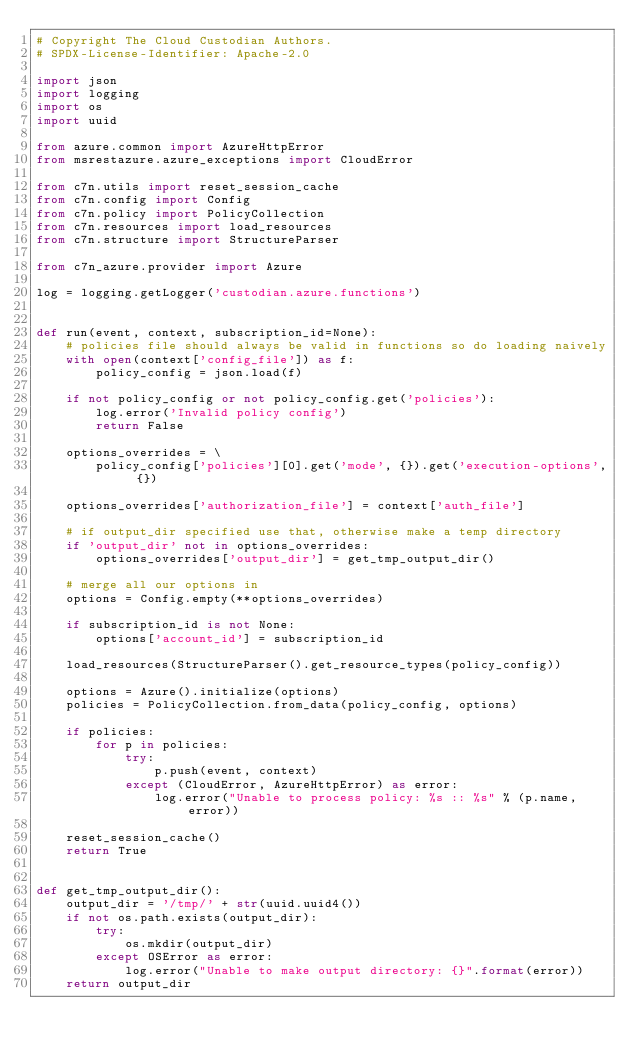Convert code to text. <code><loc_0><loc_0><loc_500><loc_500><_Python_># Copyright The Cloud Custodian Authors.
# SPDX-License-Identifier: Apache-2.0

import json
import logging
import os
import uuid

from azure.common import AzureHttpError
from msrestazure.azure_exceptions import CloudError

from c7n.utils import reset_session_cache
from c7n.config import Config
from c7n.policy import PolicyCollection
from c7n.resources import load_resources
from c7n.structure import StructureParser

from c7n_azure.provider import Azure

log = logging.getLogger('custodian.azure.functions')


def run(event, context, subscription_id=None):
    # policies file should always be valid in functions so do loading naively
    with open(context['config_file']) as f:
        policy_config = json.load(f)

    if not policy_config or not policy_config.get('policies'):
        log.error('Invalid policy config')
        return False

    options_overrides = \
        policy_config['policies'][0].get('mode', {}).get('execution-options', {})

    options_overrides['authorization_file'] = context['auth_file']

    # if output_dir specified use that, otherwise make a temp directory
    if 'output_dir' not in options_overrides:
        options_overrides['output_dir'] = get_tmp_output_dir()

    # merge all our options in
    options = Config.empty(**options_overrides)

    if subscription_id is not None:
        options['account_id'] = subscription_id

    load_resources(StructureParser().get_resource_types(policy_config))

    options = Azure().initialize(options)
    policies = PolicyCollection.from_data(policy_config, options)

    if policies:
        for p in policies:
            try:
                p.push(event, context)
            except (CloudError, AzureHttpError) as error:
                log.error("Unable to process policy: %s :: %s" % (p.name, error))

    reset_session_cache()
    return True


def get_tmp_output_dir():
    output_dir = '/tmp/' + str(uuid.uuid4())
    if not os.path.exists(output_dir):
        try:
            os.mkdir(output_dir)
        except OSError as error:
            log.error("Unable to make output directory: {}".format(error))
    return output_dir
</code> 